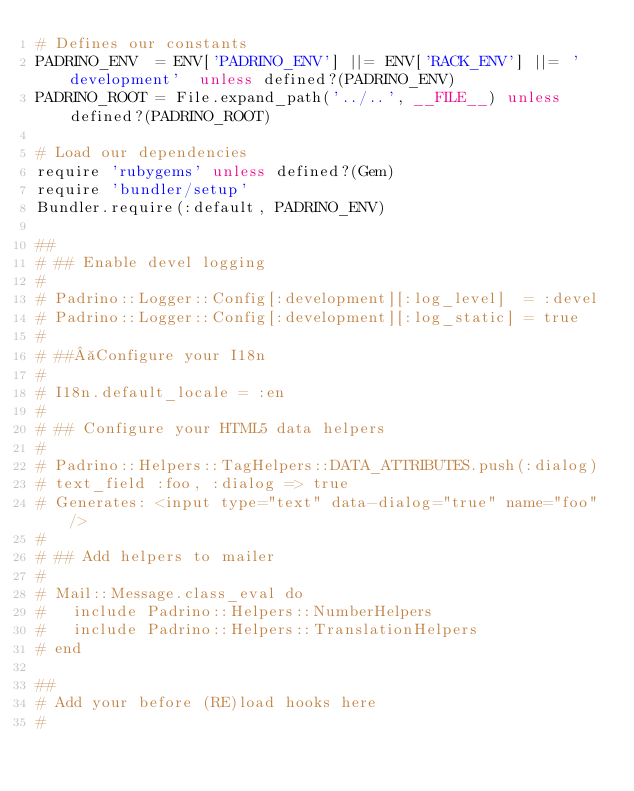Convert code to text. <code><loc_0><loc_0><loc_500><loc_500><_Ruby_># Defines our constants
PADRINO_ENV  = ENV['PADRINO_ENV'] ||= ENV['RACK_ENV'] ||= 'development'  unless defined?(PADRINO_ENV)
PADRINO_ROOT = File.expand_path('../..', __FILE__) unless defined?(PADRINO_ROOT)

# Load our dependencies
require 'rubygems' unless defined?(Gem)
require 'bundler/setup'
Bundler.require(:default, PADRINO_ENV)

##
# ## Enable devel logging
#
# Padrino::Logger::Config[:development][:log_level]  = :devel
# Padrino::Logger::Config[:development][:log_static] = true
#
# ## Configure your I18n
#
# I18n.default_locale = :en
#
# ## Configure your HTML5 data helpers
#
# Padrino::Helpers::TagHelpers::DATA_ATTRIBUTES.push(:dialog)
# text_field :foo, :dialog => true
# Generates: <input type="text" data-dialog="true" name="foo" />
#
# ## Add helpers to mailer
#
# Mail::Message.class_eval do
#   include Padrino::Helpers::NumberHelpers
#   include Padrino::Helpers::TranslationHelpers
# end

##
# Add your before (RE)load hooks here
#
</code> 